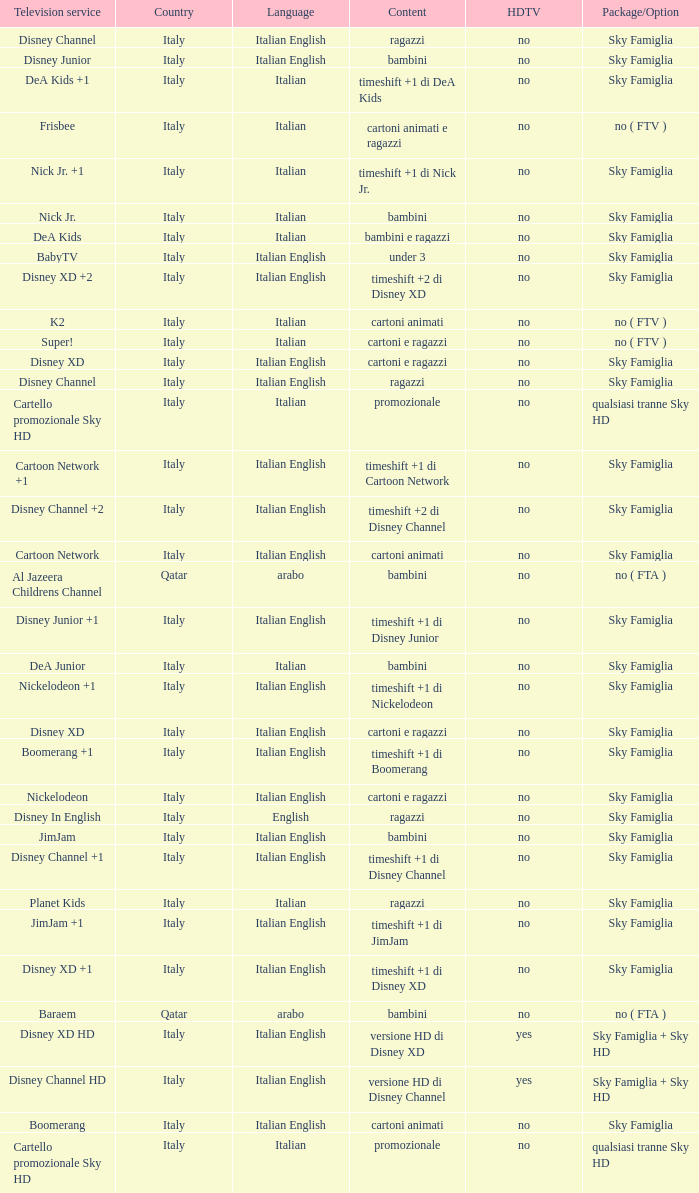What is the Country when the language is italian english, and the television service is disney xd +1? Italy. 